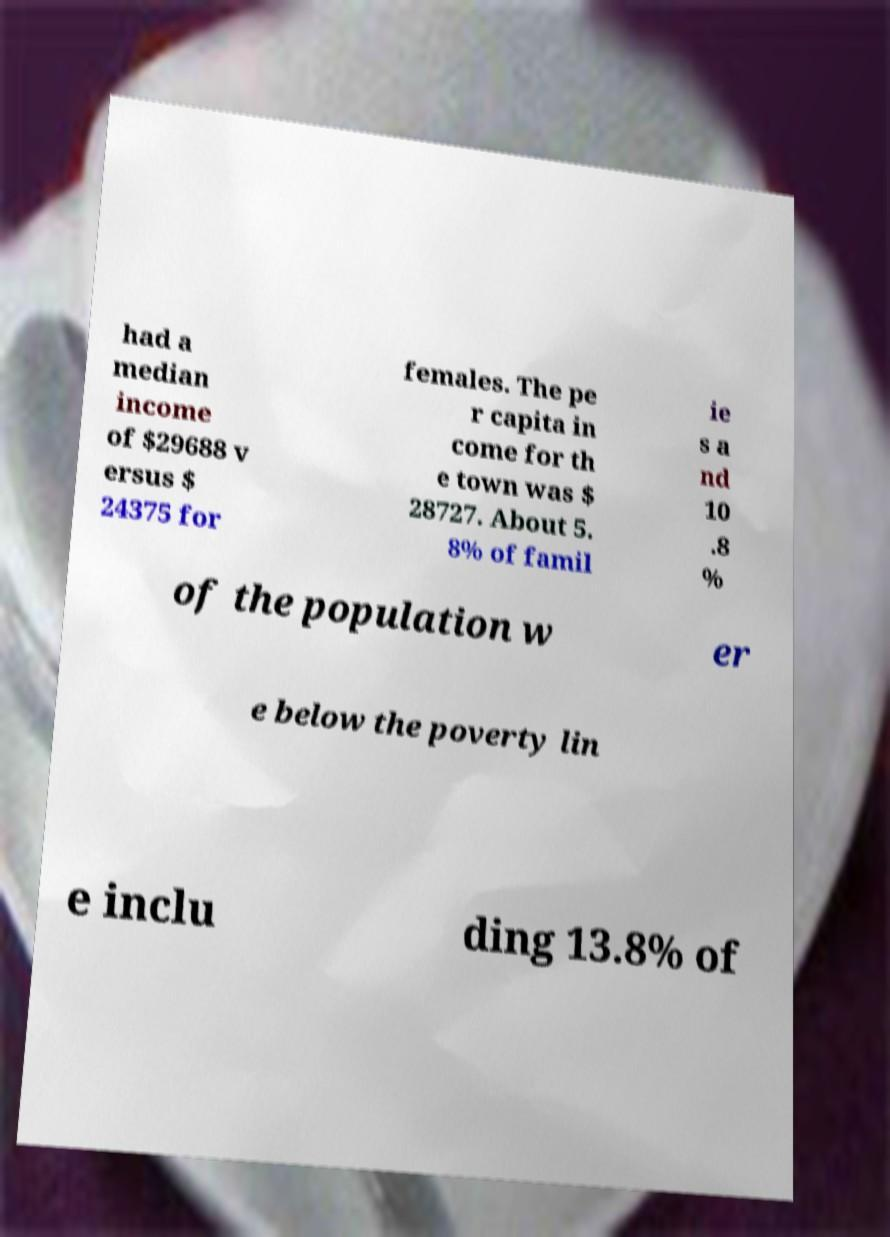Please identify and transcribe the text found in this image. had a median income of $29688 v ersus $ 24375 for females. The pe r capita in come for th e town was $ 28727. About 5. 8% of famil ie s a nd 10 .8 % of the population w er e below the poverty lin e inclu ding 13.8% of 